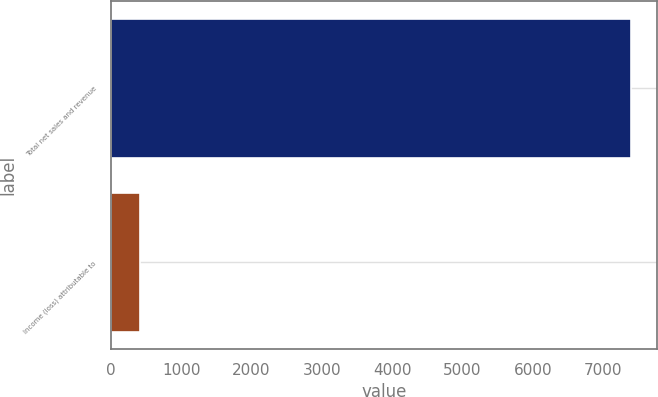<chart> <loc_0><loc_0><loc_500><loc_500><bar_chart><fcel>Total net sales and revenue<fcel>Income (loss) attributable to<nl><fcel>7399<fcel>417<nl></chart> 